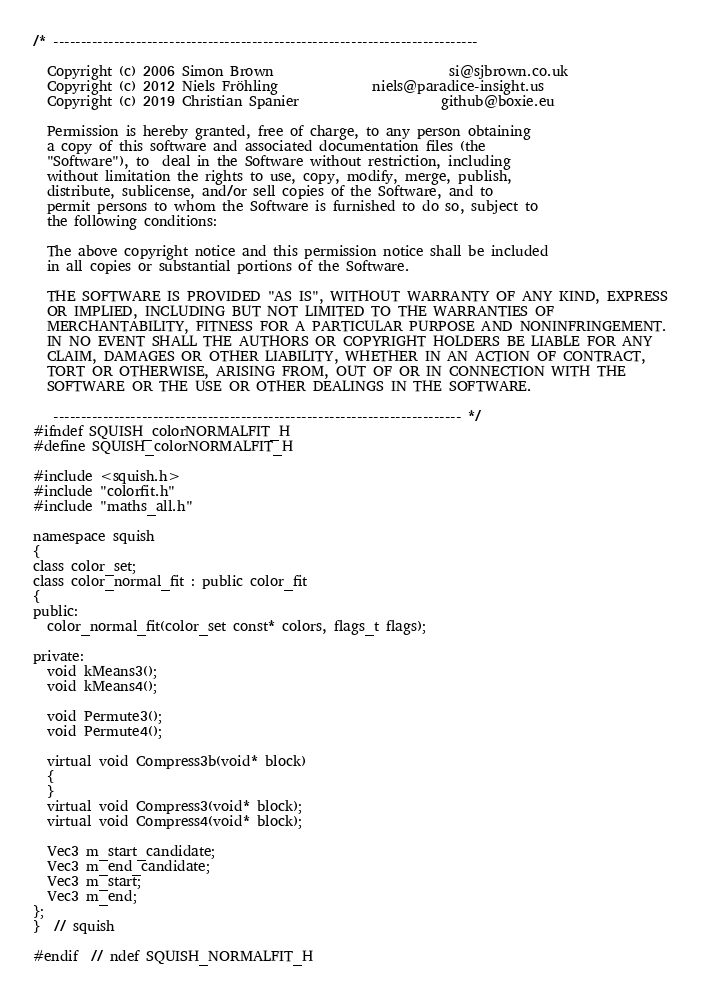Convert code to text. <code><loc_0><loc_0><loc_500><loc_500><_C_>/* -----------------------------------------------------------------------------

  Copyright (c) 2006 Simon Brown                          si@sjbrown.co.uk
  Copyright (c) 2012 Niels Fröhling              niels@paradice-insight.us
  Copyright (c) 2019 Christian Spanier                     github@boxie.eu

  Permission is hereby granted, free of charge, to any person obtaining
  a copy of this software and associated documentation files (the
  "Software"), to  deal in the Software without restriction, including
  without limitation the rights to use, copy, modify, merge, publish,
  distribute, sublicense, and/or sell copies of the Software, and to
  permit persons to whom the Software is furnished to do so, subject to
  the following conditions:

  The above copyright notice and this permission notice shall be included
  in all copies or substantial portions of the Software.

  THE SOFTWARE IS PROVIDED "AS IS", WITHOUT WARRANTY OF ANY KIND, EXPRESS
  OR IMPLIED, INCLUDING BUT NOT LIMITED TO THE WARRANTIES OF
  MERCHANTABILITY, FITNESS FOR A PARTICULAR PURPOSE AND NONINFRINGEMENT.
  IN NO EVENT SHALL THE AUTHORS OR COPYRIGHT HOLDERS BE LIABLE FOR ANY
  CLAIM, DAMAGES OR OTHER LIABILITY, WHETHER IN AN ACTION OF CONTRACT,
  TORT OR OTHERWISE, ARISING FROM, OUT OF OR IN CONNECTION WITH THE
  SOFTWARE OR THE USE OR OTHER DEALINGS IN THE SOFTWARE.

   -------------------------------------------------------------------------- */
#ifndef SQUISH_colorNORMALFIT_H
#define SQUISH_colorNORMALFIT_H

#include <squish.h>
#include "colorfit.h"
#include "maths_all.h"

namespace squish
{
class color_set;
class color_normal_fit : public color_fit
{
public:
  color_normal_fit(color_set const* colors, flags_t flags);

private:
  void kMeans3();
  void kMeans4();

  void Permute3();
  void Permute4();

  virtual void Compress3b(void* block)
  {
  }
  virtual void Compress3(void* block);
  virtual void Compress4(void* block);

  Vec3 m_start_candidate;
  Vec3 m_end_candidate;
  Vec3 m_start;
  Vec3 m_end;
};
}  // squish

#endif  // ndef SQUISH_NORMALFIT_H
</code> 